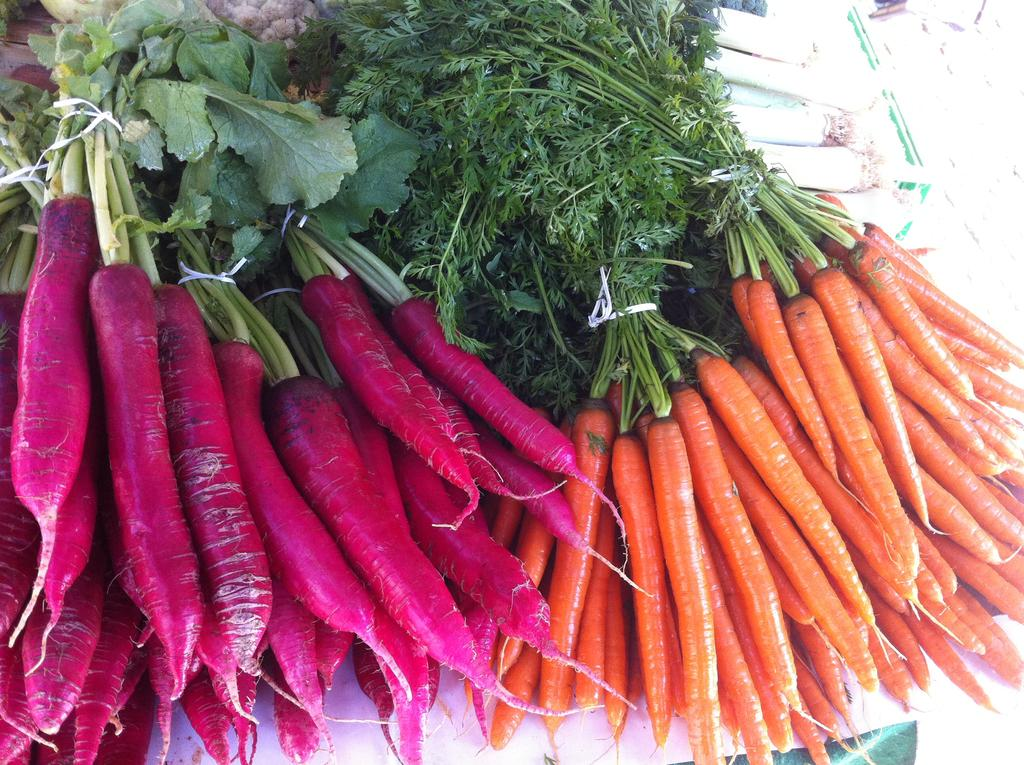What type of vegetables are present in the image? There are pink radishes and carrots in the image. Can you describe the color of the pink radishes? The pink radishes have a pink color. What type of hammer is being used to cut the dress in the image? There is no hammer or dress present in the image; it only features pink radishes and carrots. 